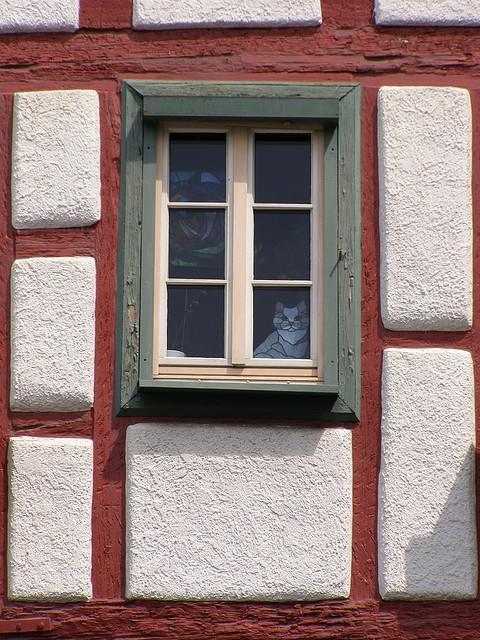How many people are wearing pink shirt?
Give a very brief answer. 0. 